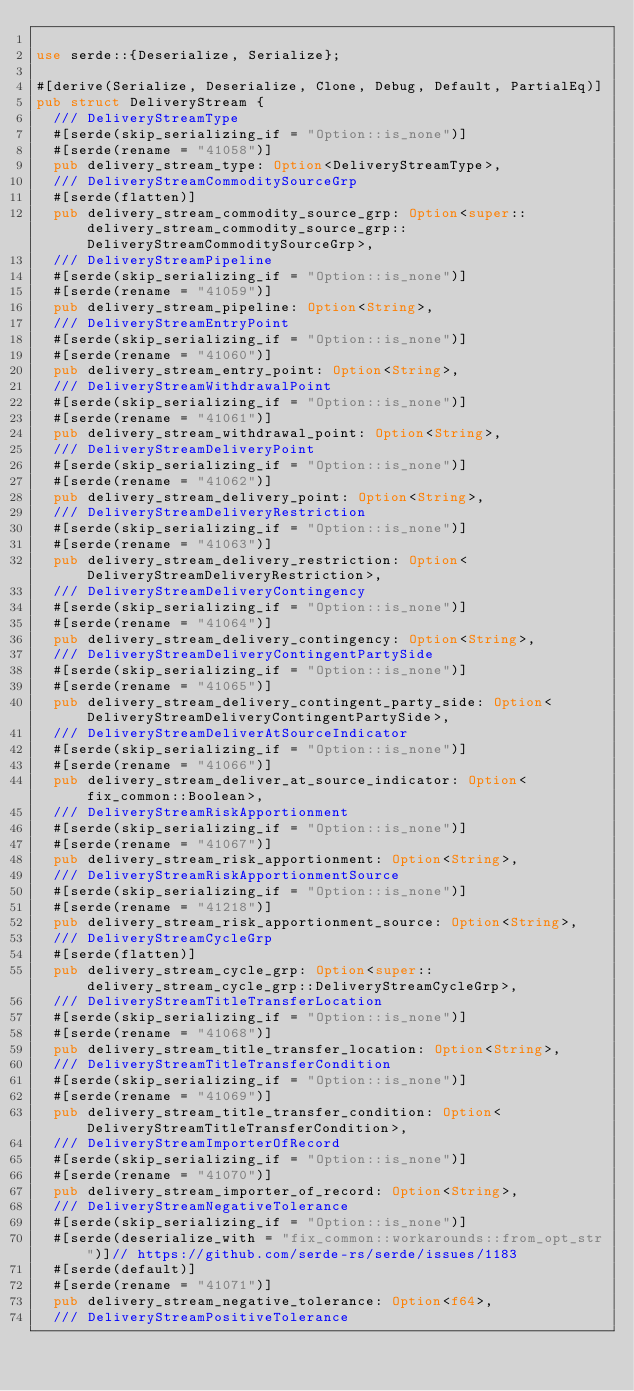<code> <loc_0><loc_0><loc_500><loc_500><_Rust_>
use serde::{Deserialize, Serialize};

#[derive(Serialize, Deserialize, Clone, Debug, Default, PartialEq)]
pub struct DeliveryStream {
	/// DeliveryStreamType
	#[serde(skip_serializing_if = "Option::is_none")]
	#[serde(rename = "41058")]
	pub delivery_stream_type: Option<DeliveryStreamType>,
	/// DeliveryStreamCommoditySourceGrp
	#[serde(flatten)]
	pub delivery_stream_commodity_source_grp: Option<super::delivery_stream_commodity_source_grp::DeliveryStreamCommoditySourceGrp>,
	/// DeliveryStreamPipeline
	#[serde(skip_serializing_if = "Option::is_none")]
	#[serde(rename = "41059")]
	pub delivery_stream_pipeline: Option<String>,
	/// DeliveryStreamEntryPoint
	#[serde(skip_serializing_if = "Option::is_none")]
	#[serde(rename = "41060")]
	pub delivery_stream_entry_point: Option<String>,
	/// DeliveryStreamWithdrawalPoint
	#[serde(skip_serializing_if = "Option::is_none")]
	#[serde(rename = "41061")]
	pub delivery_stream_withdrawal_point: Option<String>,
	/// DeliveryStreamDeliveryPoint
	#[serde(skip_serializing_if = "Option::is_none")]
	#[serde(rename = "41062")]
	pub delivery_stream_delivery_point: Option<String>,
	/// DeliveryStreamDeliveryRestriction
	#[serde(skip_serializing_if = "Option::is_none")]
	#[serde(rename = "41063")]
	pub delivery_stream_delivery_restriction: Option<DeliveryStreamDeliveryRestriction>,
	/// DeliveryStreamDeliveryContingency
	#[serde(skip_serializing_if = "Option::is_none")]
	#[serde(rename = "41064")]
	pub delivery_stream_delivery_contingency: Option<String>,
	/// DeliveryStreamDeliveryContingentPartySide
	#[serde(skip_serializing_if = "Option::is_none")]
	#[serde(rename = "41065")]
	pub delivery_stream_delivery_contingent_party_side: Option<DeliveryStreamDeliveryContingentPartySide>,
	/// DeliveryStreamDeliverAtSourceIndicator
	#[serde(skip_serializing_if = "Option::is_none")]
	#[serde(rename = "41066")]
	pub delivery_stream_deliver_at_source_indicator: Option<fix_common::Boolean>,
	/// DeliveryStreamRiskApportionment
	#[serde(skip_serializing_if = "Option::is_none")]
	#[serde(rename = "41067")]
	pub delivery_stream_risk_apportionment: Option<String>,
	/// DeliveryStreamRiskApportionmentSource
	#[serde(skip_serializing_if = "Option::is_none")]
	#[serde(rename = "41218")]
	pub delivery_stream_risk_apportionment_source: Option<String>,
	/// DeliveryStreamCycleGrp
	#[serde(flatten)]
	pub delivery_stream_cycle_grp: Option<super::delivery_stream_cycle_grp::DeliveryStreamCycleGrp>,
	/// DeliveryStreamTitleTransferLocation
	#[serde(skip_serializing_if = "Option::is_none")]
	#[serde(rename = "41068")]
	pub delivery_stream_title_transfer_location: Option<String>,
	/// DeliveryStreamTitleTransferCondition
	#[serde(skip_serializing_if = "Option::is_none")]
	#[serde(rename = "41069")]
	pub delivery_stream_title_transfer_condition: Option<DeliveryStreamTitleTransferCondition>,
	/// DeliveryStreamImporterOfRecord
	#[serde(skip_serializing_if = "Option::is_none")]
	#[serde(rename = "41070")]
	pub delivery_stream_importer_of_record: Option<String>,
	/// DeliveryStreamNegativeTolerance
	#[serde(skip_serializing_if = "Option::is_none")]
	#[serde(deserialize_with = "fix_common::workarounds::from_opt_str")]// https://github.com/serde-rs/serde/issues/1183
	#[serde(default)]
	#[serde(rename = "41071")]
	pub delivery_stream_negative_tolerance: Option<f64>,
	/// DeliveryStreamPositiveTolerance</code> 